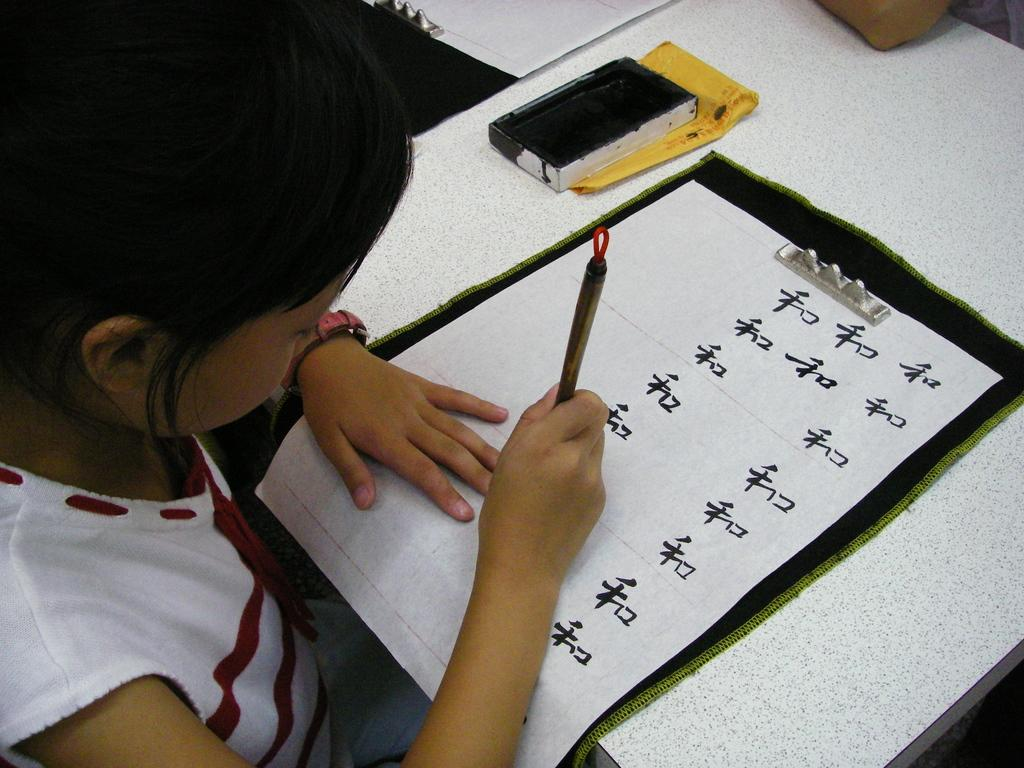What is the main subject of the image? There is a kid in the image. What is the kid interacting with in the image? There is paper in the image, which the kid might be interacting with. What is the setting of the image? There is a table in the image, suggesting that the kid is in a room or indoor setting. What other objects can be seen in the image? There are other objects in the image, but their specific details are not mentioned in the provided facts. What type of rings is the kid wearing in the image? There is no mention of rings in the provided facts, so we cannot determine if the kid is wearing any rings in the image. 